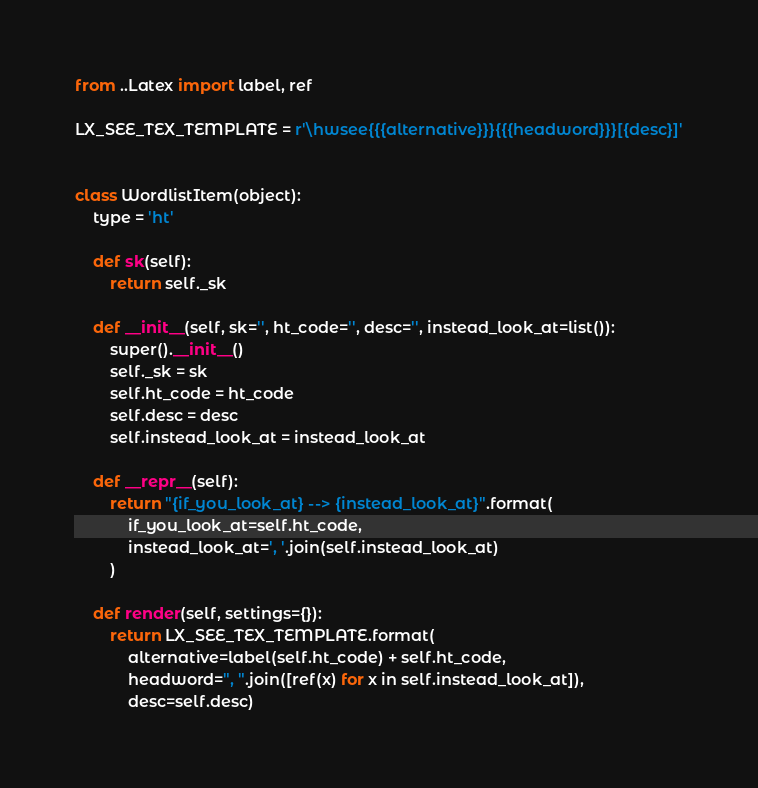Convert code to text. <code><loc_0><loc_0><loc_500><loc_500><_Python_>from ..Latex import label, ref

LX_SEE_TEX_TEMPLATE = r'\hwsee{{{alternative}}}{{{headword}}}[{desc}]'


class WordlistItem(object):
    type = 'ht'

    def sk(self):
        return self._sk

    def __init__(self, sk='', ht_code='', desc='', instead_look_at=list()):
        super().__init__()
        self._sk = sk
        self.ht_code = ht_code
        self.desc = desc
        self.instead_look_at = instead_look_at

    def __repr__(self):
        return "{if_you_look_at} --> {instead_look_at}".format(
            if_you_look_at=self.ht_code,
            instead_look_at=', '.join(self.instead_look_at)
        )

    def render(self, settings={}):
        return LX_SEE_TEX_TEMPLATE.format(
            alternative=label(self.ht_code) + self.ht_code,
            headword=", ".join([ref(x) for x in self.instead_look_at]),
            desc=self.desc)
</code> 